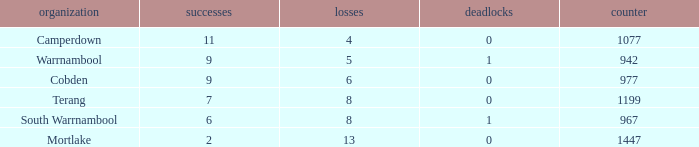How many draws did Mortlake have when the losses were more than 5? 1.0. 